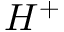Convert formula to latex. <formula><loc_0><loc_0><loc_500><loc_500>H ^ { + }</formula> 